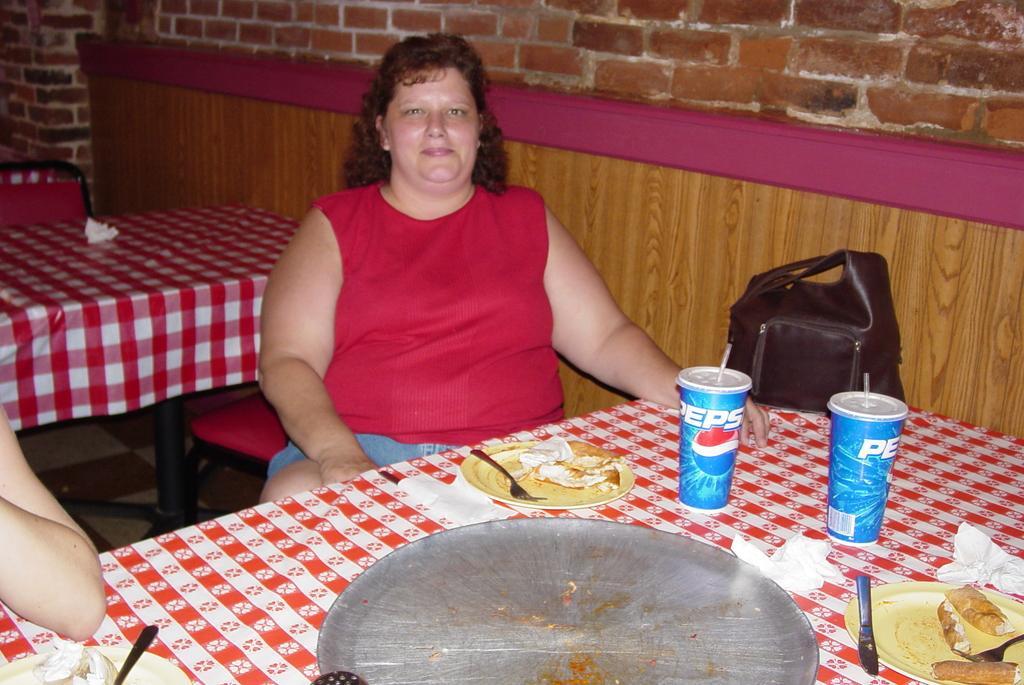Can you describe this image briefly? In this image there is a woman sitting on the chair, there is a person's hand towards the left of the image, there are tables, there are clothes on the table, there are objects on the cloth, there is a wooden wall towards the right of the image, there is a brick wall towards the top of the image. 